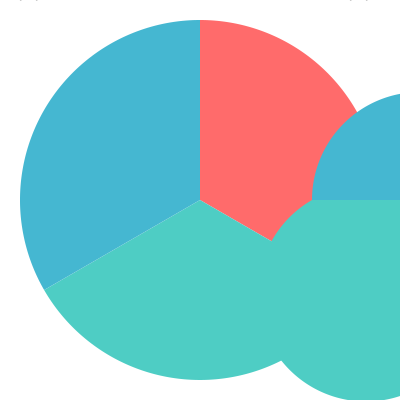Based on the pie charts showing demographic shifts in immigrant communities from 2010 to 2020, which group experienced the most significant proportional increase, and by approximately what percentage? To determine which group experienced the most significant proportional increase and by what percentage, we need to compare the relative sizes of each segment in 2010 and 2020:

1. Latin American (red):
   2010: Approximately 33% (120° out of 360°)
   2020: Approximately 25% (90° out of 360°)
   Decrease in proportion

2. Asian (green):
   2010: Approximately 33% (120° out of 360°)
   2020: Approximately 50% (180° out of 360°)
   Increase from 33% to 50%

3. Other (blue):
   2010: Approximately 33% (120° out of 360°)
   2020: Approximately 25% (90° out of 360°)
   Decrease in proportion

The Asian group experienced the most significant proportional increase.

To calculate the percentage increase:
$\text{Percentage increase} = \frac{\text{New value} - \text{Original value}}{\text{Original value}} \times 100\%$

$\text{Percentage increase} = \frac{50\% - 33\%}{33\%} \times 100\% \approx 51.5\%$

Rounding to the nearest whole number, the Asian group increased by approximately 52%.
Answer: Asian group, by approximately 52% 